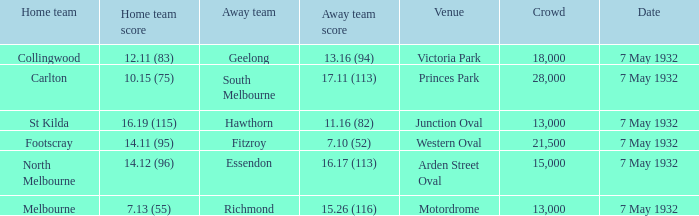16 (94)? 18000.0. 